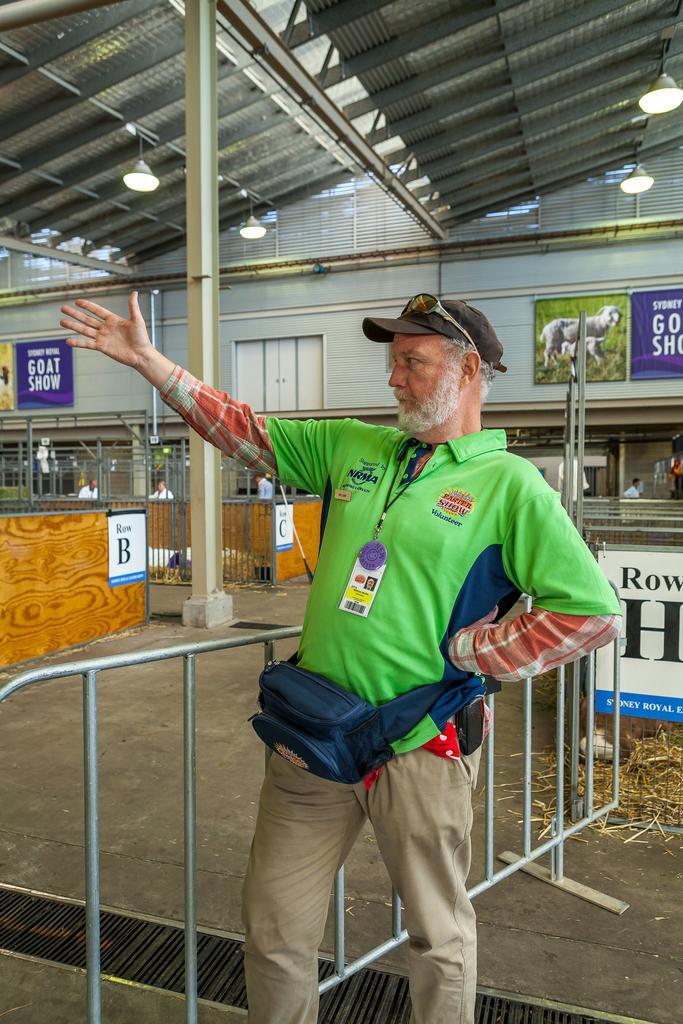Please provide a concise description of this image. In this picture there is a person standing in the foreground. At the back there is a railing and there are hoardings and there are group of people standing. At the top there is a roof and there are lights. 